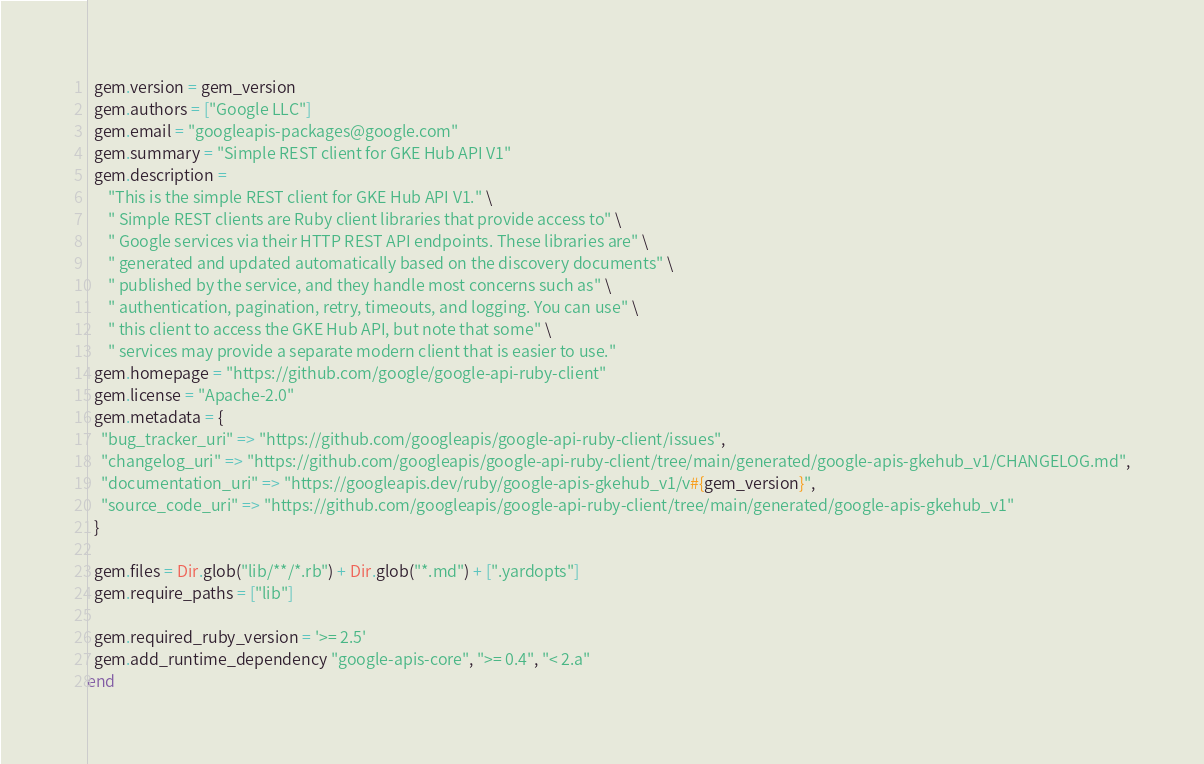Convert code to text. <code><loc_0><loc_0><loc_500><loc_500><_Ruby_>  gem.version = gem_version
  gem.authors = ["Google LLC"]
  gem.email = "googleapis-packages@google.com"
  gem.summary = "Simple REST client for GKE Hub API V1"
  gem.description =
      "This is the simple REST client for GKE Hub API V1." \
      " Simple REST clients are Ruby client libraries that provide access to" \
      " Google services via their HTTP REST API endpoints. These libraries are" \
      " generated and updated automatically based on the discovery documents" \
      " published by the service, and they handle most concerns such as" \
      " authentication, pagination, retry, timeouts, and logging. You can use" \
      " this client to access the GKE Hub API, but note that some" \
      " services may provide a separate modern client that is easier to use."
  gem.homepage = "https://github.com/google/google-api-ruby-client"
  gem.license = "Apache-2.0"
  gem.metadata = {
    "bug_tracker_uri" => "https://github.com/googleapis/google-api-ruby-client/issues",
    "changelog_uri" => "https://github.com/googleapis/google-api-ruby-client/tree/main/generated/google-apis-gkehub_v1/CHANGELOG.md",
    "documentation_uri" => "https://googleapis.dev/ruby/google-apis-gkehub_v1/v#{gem_version}",
    "source_code_uri" => "https://github.com/googleapis/google-api-ruby-client/tree/main/generated/google-apis-gkehub_v1"
  }

  gem.files = Dir.glob("lib/**/*.rb") + Dir.glob("*.md") + [".yardopts"]
  gem.require_paths = ["lib"]

  gem.required_ruby_version = '>= 2.5'
  gem.add_runtime_dependency "google-apis-core", ">= 0.4", "< 2.a"
end
</code> 